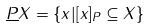Convert formula to latex. <formula><loc_0><loc_0><loc_500><loc_500>\underline { P } X = \{ x | [ x ] _ { P } \subseteq X \}</formula> 